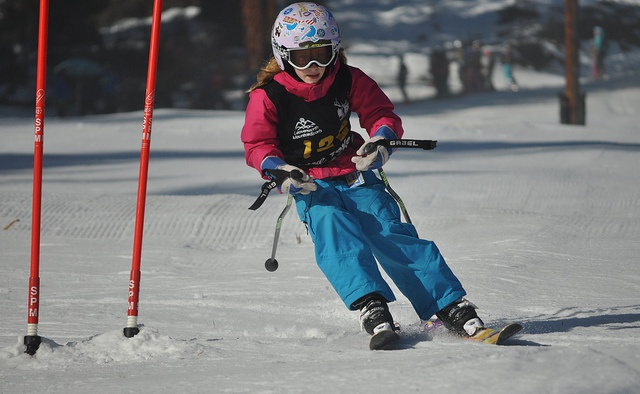Describe the objects in this image and their specific colors. I can see people in black, darkblue, teal, and darkgray tones, skis in black, gray, darkgray, and tan tones, and people in black, gray, and purple tones in this image. 